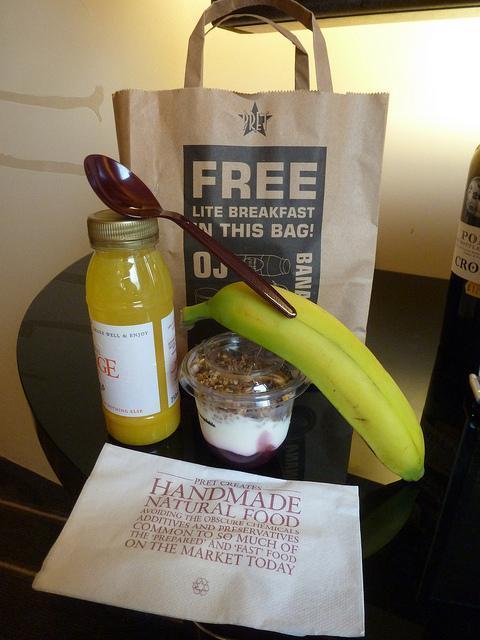How many bottles can be seen?
Give a very brief answer. 2. How many dining tables can be seen?
Give a very brief answer. 1. 